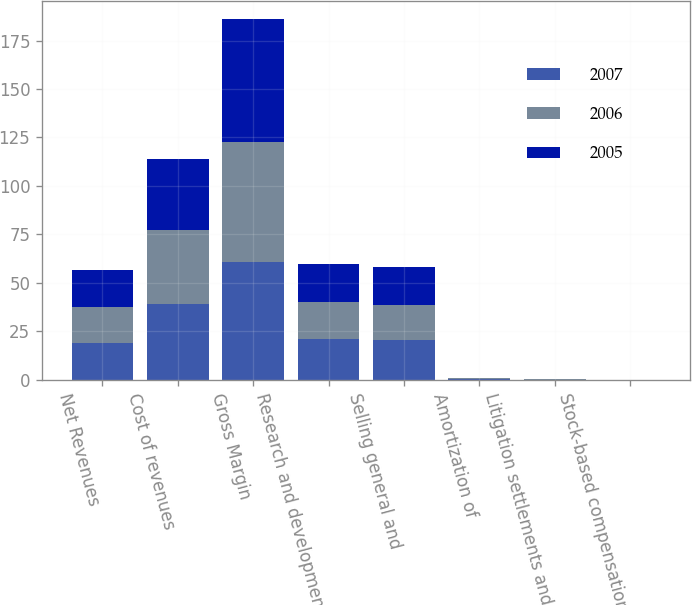Convert chart to OTSL. <chart><loc_0><loc_0><loc_500><loc_500><stacked_bar_chart><ecel><fcel>Net Revenues<fcel>Cost of revenues<fcel>Gross Margin<fcel>Research and development<fcel>Selling general and<fcel>Amortization of<fcel>Litigation settlements and<fcel>Stock-based compensation<nl><fcel>2007<fcel>18.9<fcel>39<fcel>61<fcel>21.1<fcel>20.4<fcel>0.4<fcel>0.1<fcel>0.1<nl><fcel>2006<fcel>18.9<fcel>38.1<fcel>61.9<fcel>18.9<fcel>18.3<fcel>0.4<fcel>0.2<fcel>0<nl><fcel>2005<fcel>18.9<fcel>36.6<fcel>63.4<fcel>19.6<fcel>19.3<fcel>0.4<fcel>0<fcel>0<nl></chart> 